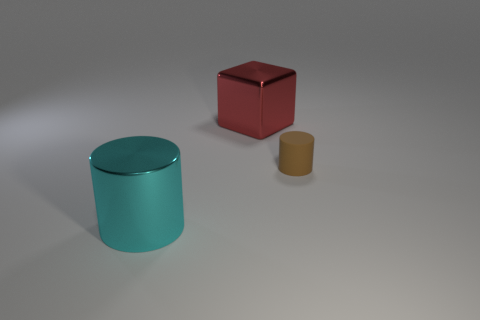Add 2 tiny gray metallic cylinders. How many objects exist? 5 Subtract all cyan cylinders. How many cylinders are left? 1 Subtract all large yellow shiny objects. Subtract all rubber cylinders. How many objects are left? 2 Add 2 small brown rubber objects. How many small brown rubber objects are left? 3 Add 2 small gray metallic cylinders. How many small gray metallic cylinders exist? 2 Subtract 1 brown cylinders. How many objects are left? 2 Subtract all cylinders. How many objects are left? 1 Subtract all gray cylinders. Subtract all gray spheres. How many cylinders are left? 2 